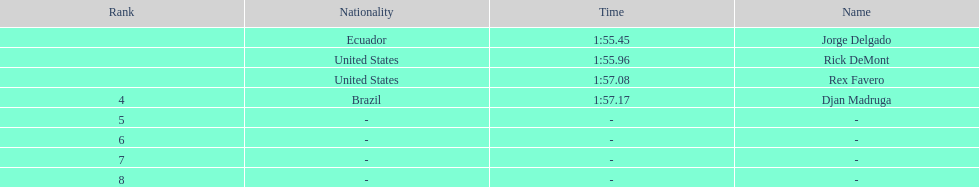How many ranked swimmers were from the united states? 2. 